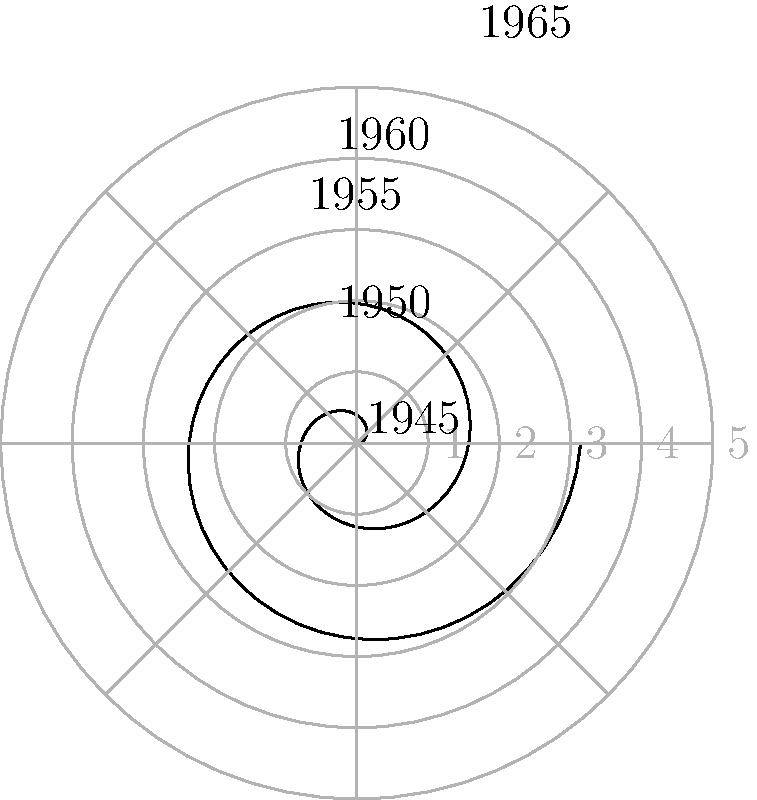In the polar coordinate system shown, the spread of communism in Eastern Europe from 1945 to 1965 is represented by a spiral. The angle represents the year, with each full rotation corresponding to 5 years, and the radius represents the number of countries under communist rule. If the spiral makes exactly two complete rotations from 1945 to 1965, what is the rate of increase in the number of communist countries per year? Let's approach this step-by-step:

1) First, we need to understand what the spiral represents:
   - Each full rotation (360°) represents 5 years
   - The radius represents the number of countries under communist rule

2) We're told that from 1945 to 1965, the spiral makes exactly two complete rotations. This means:
   - Total time span = 20 years
   - Total angular rotation = 2 * 360° = 720°

3) Now, let's look at the radial increase:
   - The spiral starts at the center (r = 0) in 1945
   - At the end of two rotations (1965), the radius has increased to 5

4) So, over 20 years, the number of communist countries increased from 0 to 5.

5) To find the rate of increase per year, we calculate:
   $$ \text{Rate} = \frac{\text{Total increase}}{\text{Time span}} = \frac{5 - 0}{20} = \frac{5}{20} = 0.25 $$

Therefore, the rate of increase in the number of communist countries is 0.25 per year.
Answer: 0.25 countries per year 